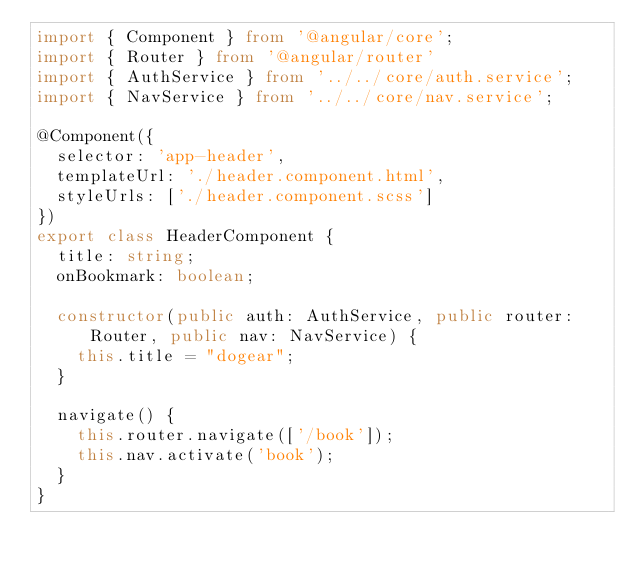<code> <loc_0><loc_0><loc_500><loc_500><_TypeScript_>import { Component } from '@angular/core';
import { Router } from '@angular/router'
import { AuthService } from '../../core/auth.service';
import { NavService } from '../../core/nav.service';

@Component({
  selector: 'app-header',
  templateUrl: './header.component.html',
  styleUrls: ['./header.component.scss']
})
export class HeaderComponent {
  title: string;
  onBookmark: boolean;

  constructor(public auth: AuthService, public router: Router, public nav: NavService) { 
    this.title = "dogear"; 
  }

  navigate() {
    this.router.navigate(['/book']);
    this.nav.activate('book');
  }
}
</code> 